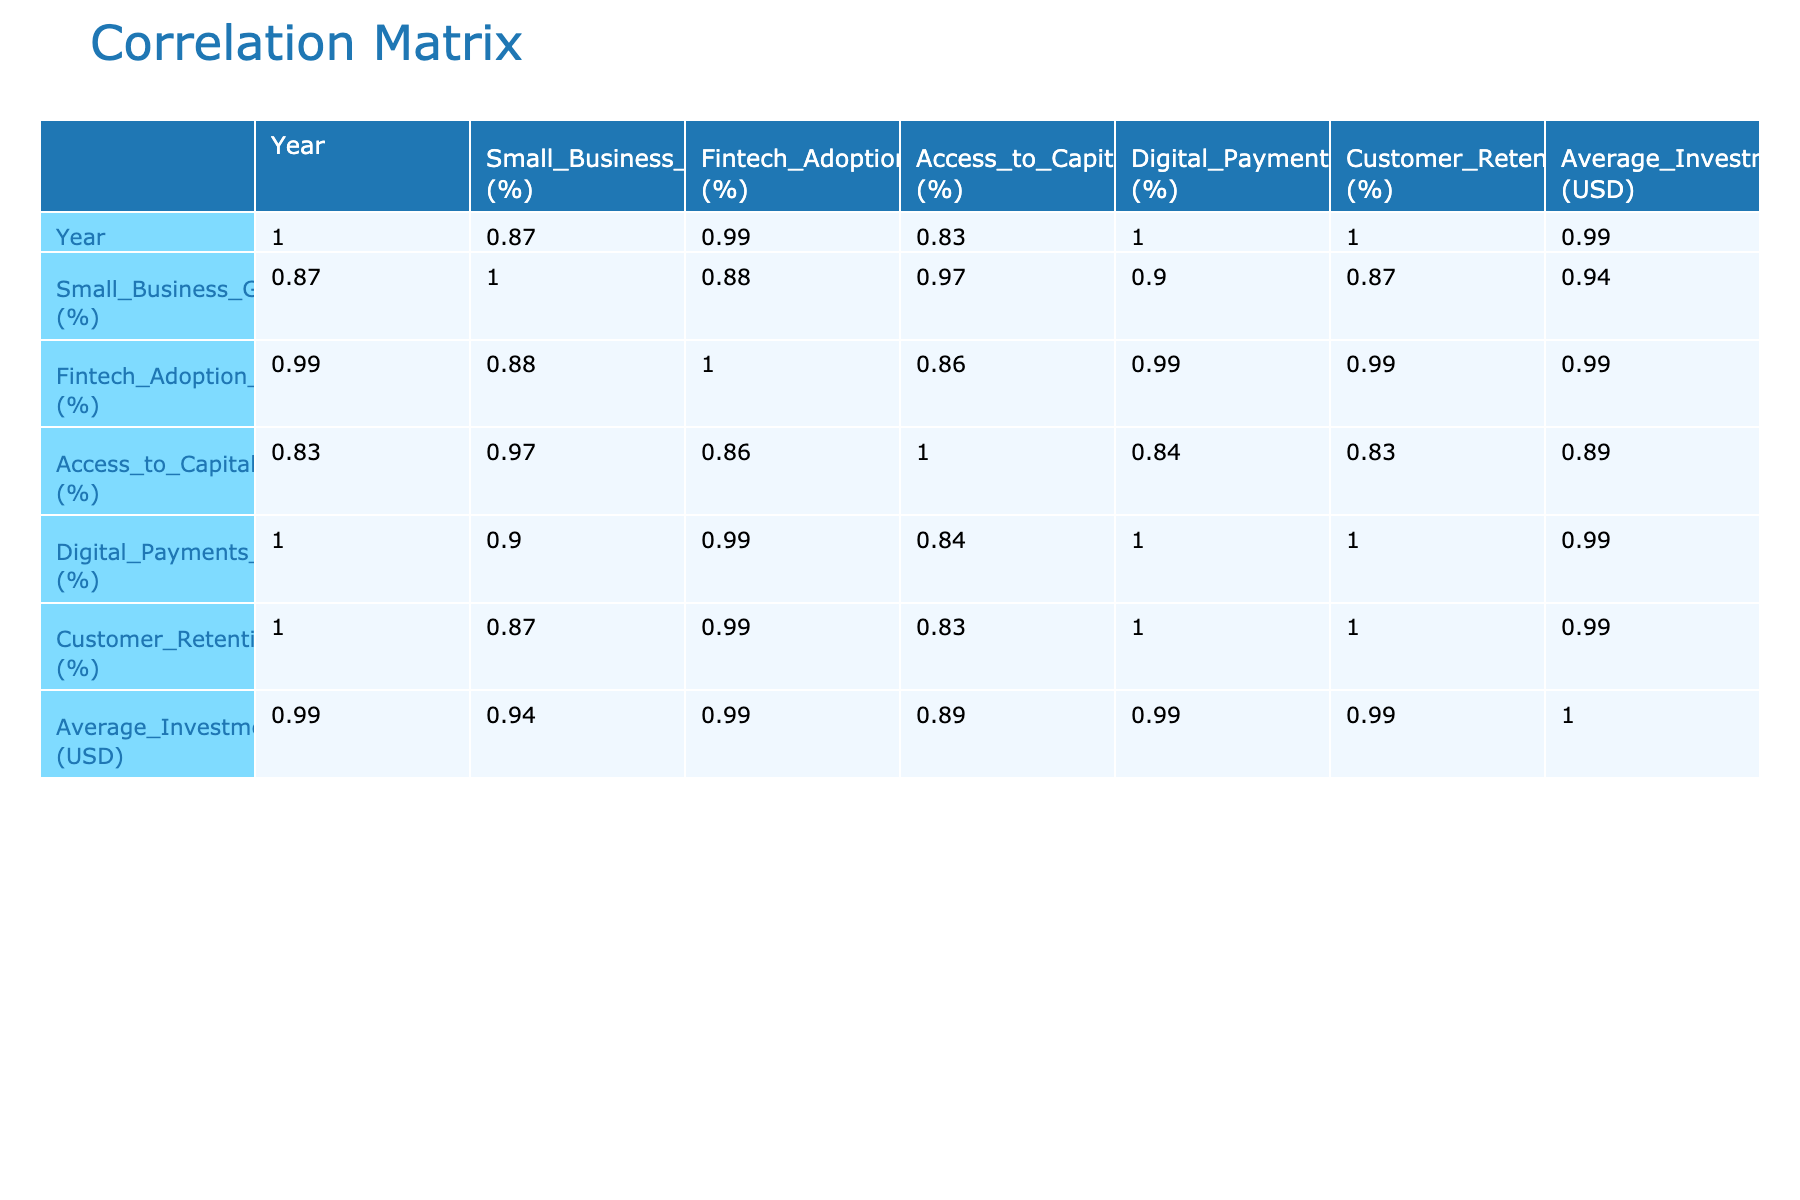What was the Small Business Growth Rate in 2021? The table shows that the Small Business Growth Rate for the year 2021 is 6.1%.
Answer: 6.1% What is the correlation coefficient between Fintech Adoption Rate and Small Business Growth Rate? Referring to the correlation table, the correlation coefficient between Fintech Adoption Rate and Small Business Growth Rate is 0.97.
Answer: 0.97 In what year did the Access to Capital percentage have its highest value, and what was that value? Looking at the table, the highest Access to Capital percentage is 80%, which occurred in 2023.
Answer: 80% in 2023 What is the difference in average investment in technology between 2018 and 2023? The average investment in technology for 2018 is 15,000 USD and for 2023 is 35,000 USD. The difference is 35,000 - 15,000 = 20,000 USD.
Answer: 20,000 USD Is the Customer Retention Rate positively correlated with Fintech Adoption Rate? The correlation table indicates a positive value of 0.96 between Customer Retention Rate and Fintech Adoption Rate, which confirms they are positively correlated.
Answer: Yes What is the average Small Business Growth Rate from 2018 to 2023? The Small Business Growth Rates from 2018 to 2023 are 5.2%, 5.5%, 4.8%, 6.1%, 7.0%, and 8.2%. Summing these gives 5.2 + 5.5 + 4.8 + 6.1 + 7.0 + 8.2 = 36.8%. Dividing by 6 (the number of years) results in an average of 36.8% / 6 = approximately 6.13%.
Answer: Approximately 6.13% What was the Fintech Adoption Rate in 2022, and how does it compare to the rate in 2019? The Fintech Adoption Rate in 2022 is 80%, while in 2019 it is 40%. Comparing the two gives us 80% - 40% = 40% increase.
Answer: 80% in 2022, 40% increase compared to 2019 Which year saw the highest usage of Digital Payments, and what was the percentage? The table shows that the highest usage of Digital Payments occurred in 2023 with a percentage of 70%.
Answer: 70% in 2023 